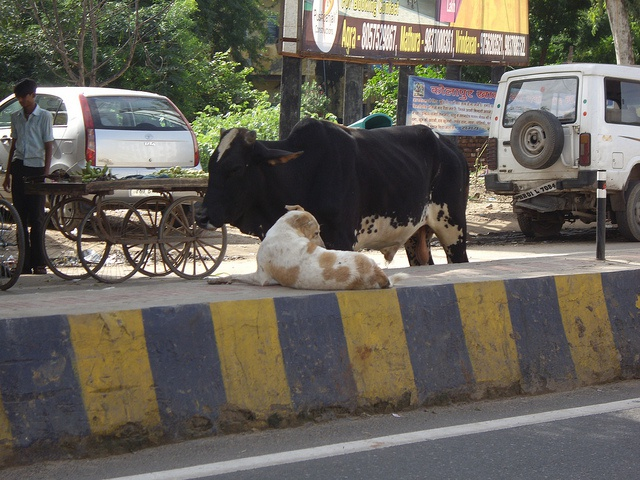Describe the objects in this image and their specific colors. I can see cow in darkgreen, black, and gray tones, truck in darkgreen, black, gray, lightgray, and darkgray tones, car in darkgreen, lightgray, gray, and darkgray tones, dog in darkgreen, darkgray, and gray tones, and people in darkgreen, black, gray, and maroon tones in this image. 